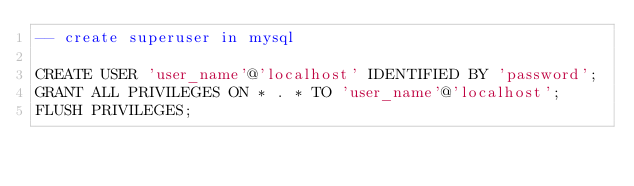<code> <loc_0><loc_0><loc_500><loc_500><_SQL_>-- create superuser in mysql

CREATE USER 'user_name'@'localhost' IDENTIFIED BY 'password';
GRANT ALL PRIVILEGES ON * . * TO 'user_name'@'localhost';
FLUSH PRIVILEGES;</code> 